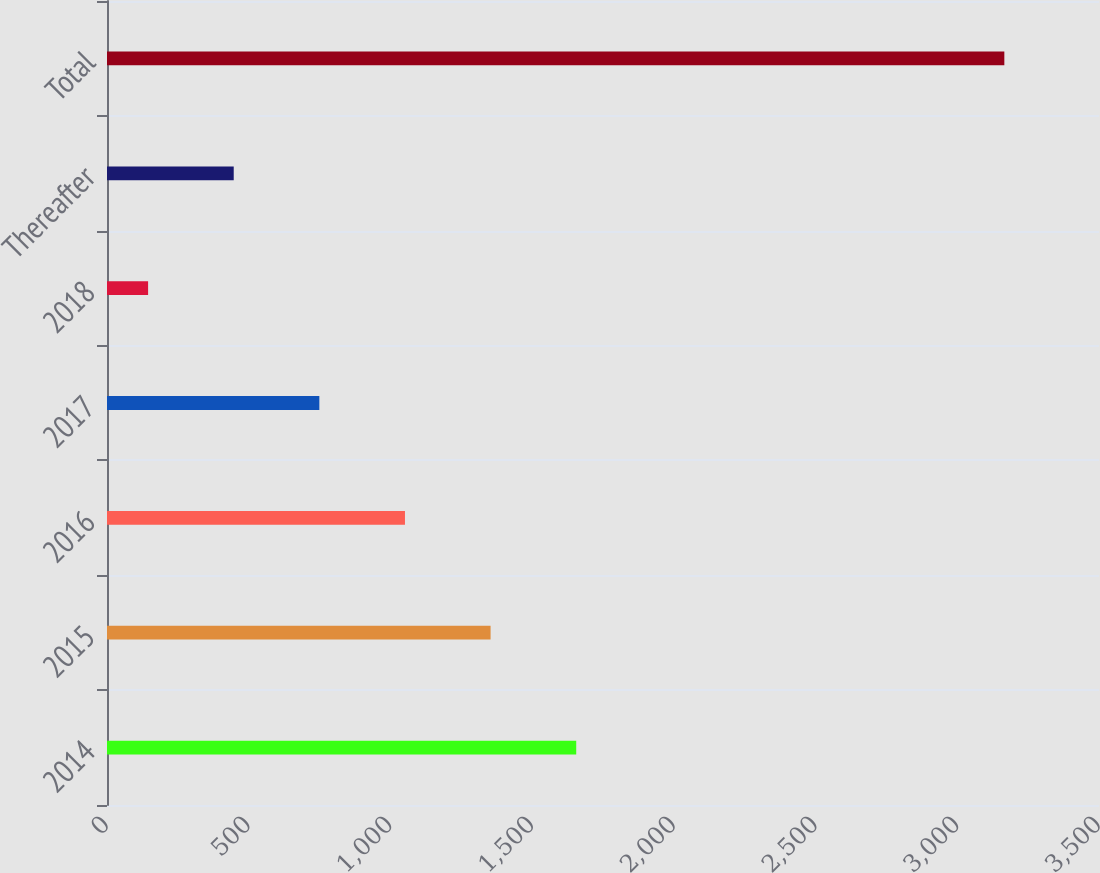Convert chart to OTSL. <chart><loc_0><loc_0><loc_500><loc_500><bar_chart><fcel>2014<fcel>2015<fcel>2016<fcel>2017<fcel>2018<fcel>Thereafter<fcel>Total<nl><fcel>1655.5<fcel>1353.4<fcel>1051.3<fcel>749.2<fcel>145<fcel>447.1<fcel>3166<nl></chart> 